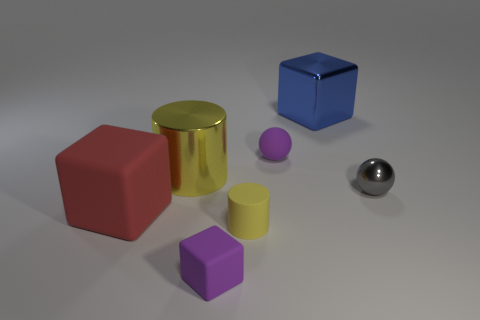How many yellow cylinders must be subtracted to get 1 yellow cylinders? 1 Subtract all matte cubes. How many cubes are left? 1 Subtract all spheres. How many objects are left? 5 Subtract 1 blocks. How many blocks are left? 2 Subtract all red cubes. Subtract all purple spheres. How many cubes are left? 2 Subtract all green cylinders. How many gray blocks are left? 0 Subtract all tiny purple balls. Subtract all blue metallic things. How many objects are left? 5 Add 5 big metal blocks. How many big metal blocks are left? 6 Add 2 green matte cylinders. How many green matte cylinders exist? 2 Add 1 tiny matte things. How many objects exist? 8 